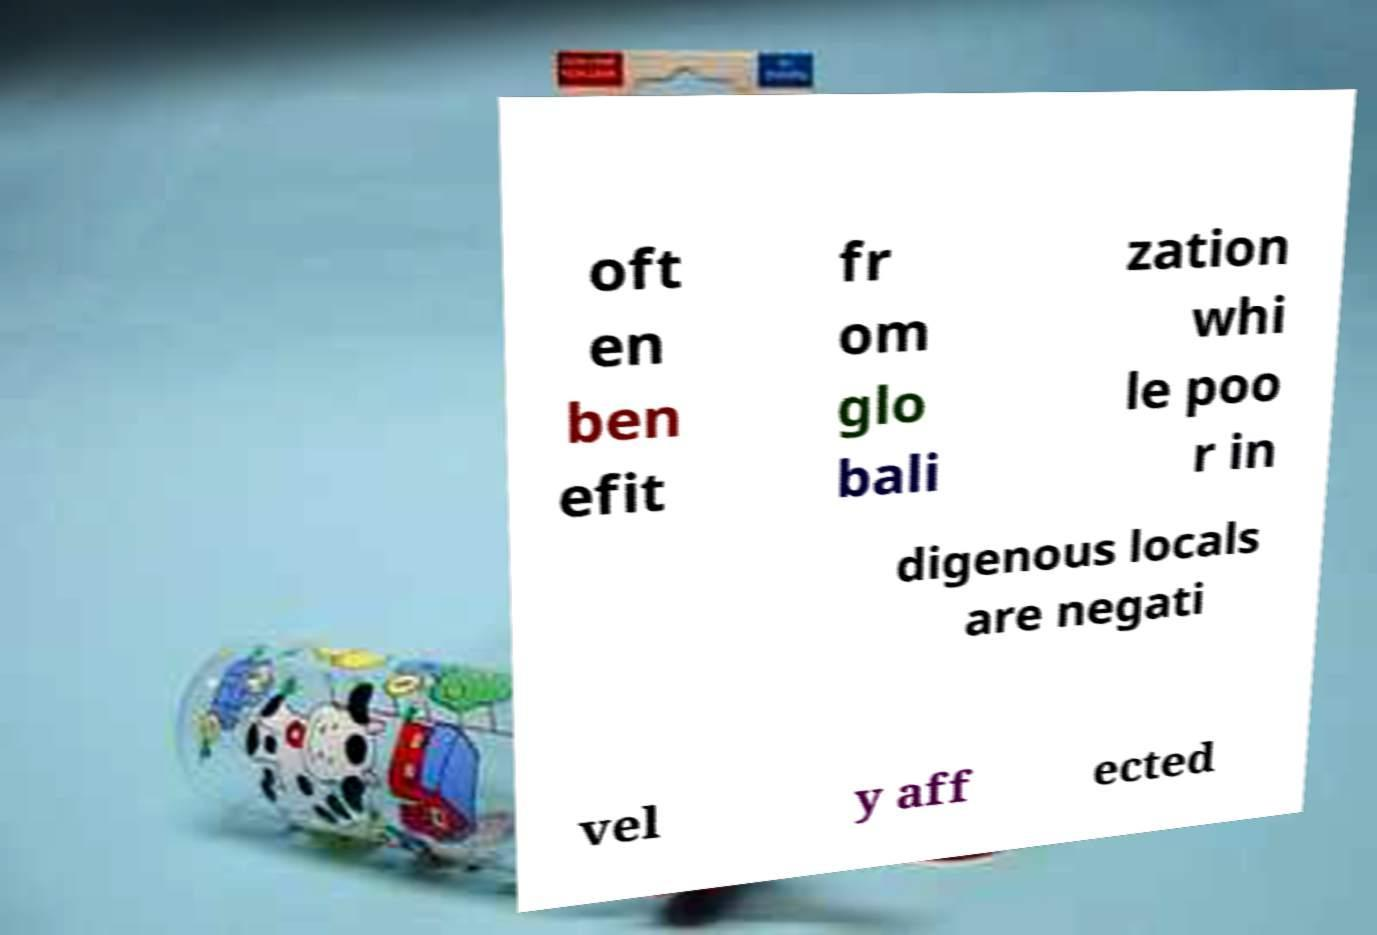Please read and relay the text visible in this image. What does it say? oft en ben efit fr om glo bali zation whi le poo r in digenous locals are negati vel y aff ected 